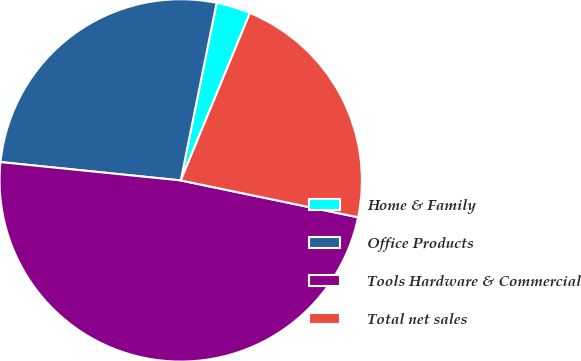Convert chart. <chart><loc_0><loc_0><loc_500><loc_500><pie_chart><fcel>Home & Family<fcel>Office Products<fcel>Tools Hardware & Commercial<fcel>Total net sales<nl><fcel>3.06%<fcel>26.56%<fcel>48.35%<fcel>22.03%<nl></chart> 